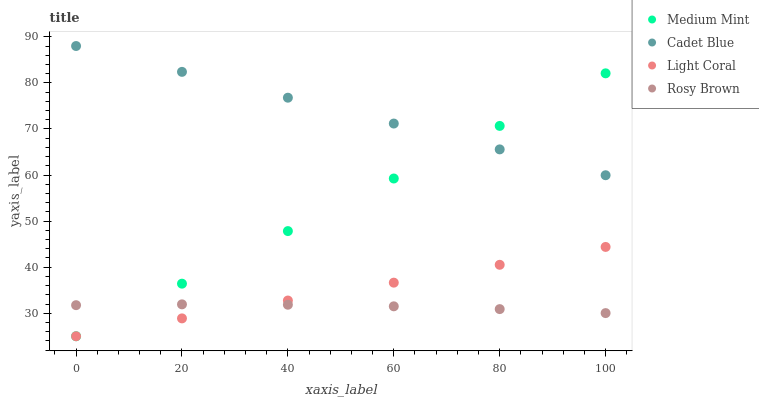Does Rosy Brown have the minimum area under the curve?
Answer yes or no. Yes. Does Cadet Blue have the maximum area under the curve?
Answer yes or no. Yes. Does Light Coral have the minimum area under the curve?
Answer yes or no. No. Does Light Coral have the maximum area under the curve?
Answer yes or no. No. Is Light Coral the smoothest?
Answer yes or no. Yes. Is Rosy Brown the roughest?
Answer yes or no. Yes. Is Rosy Brown the smoothest?
Answer yes or no. No. Is Light Coral the roughest?
Answer yes or no. No. Does Medium Mint have the lowest value?
Answer yes or no. Yes. Does Rosy Brown have the lowest value?
Answer yes or no. No. Does Cadet Blue have the highest value?
Answer yes or no. Yes. Does Light Coral have the highest value?
Answer yes or no. No. Is Light Coral less than Cadet Blue?
Answer yes or no. Yes. Is Cadet Blue greater than Light Coral?
Answer yes or no. Yes. Does Rosy Brown intersect Medium Mint?
Answer yes or no. Yes. Is Rosy Brown less than Medium Mint?
Answer yes or no. No. Is Rosy Brown greater than Medium Mint?
Answer yes or no. No. Does Light Coral intersect Cadet Blue?
Answer yes or no. No. 